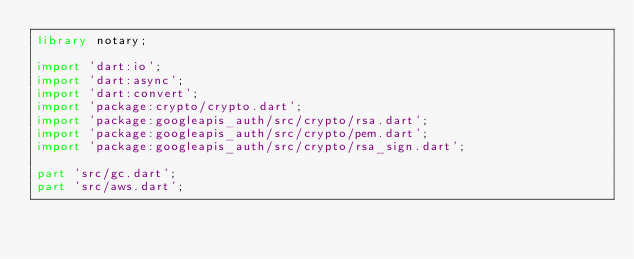Convert code to text. <code><loc_0><loc_0><loc_500><loc_500><_Dart_>library notary;

import 'dart:io';
import 'dart:async';
import 'dart:convert';
import 'package:crypto/crypto.dart';
import 'package:googleapis_auth/src/crypto/rsa.dart';
import 'package:googleapis_auth/src/crypto/pem.dart';
import 'package:googleapis_auth/src/crypto/rsa_sign.dart';

part 'src/gc.dart';
part 'src/aws.dart';</code> 